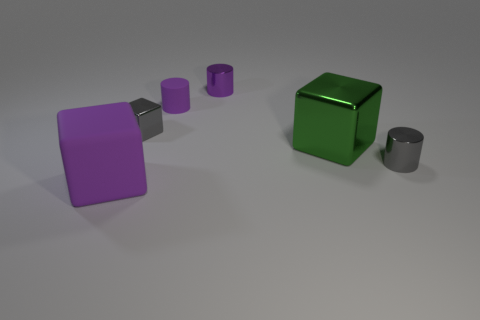What number of things are either things that are in front of the tiny gray metal block or small metallic cylinders that are behind the gray metal cylinder?
Give a very brief answer. 4. What is the color of the tiny rubber cylinder?
Offer a terse response. Purple. Is the number of green blocks that are on the left side of the tiny gray cube less than the number of large matte objects?
Your response must be concise. Yes. Is there a tiny blue cylinder?
Provide a succinct answer. No. Is the number of small yellow rubber spheres less than the number of large purple cubes?
Your answer should be compact. Yes. How many large purple things have the same material as the purple block?
Provide a succinct answer. 0. What is the color of the other cube that is the same material as the big green cube?
Make the answer very short. Gray. What is the shape of the big metal object?
Provide a short and direct response. Cube. What number of things have the same color as the small cube?
Offer a very short reply. 1. What shape is the purple object that is the same size as the purple shiny cylinder?
Offer a terse response. Cylinder. 